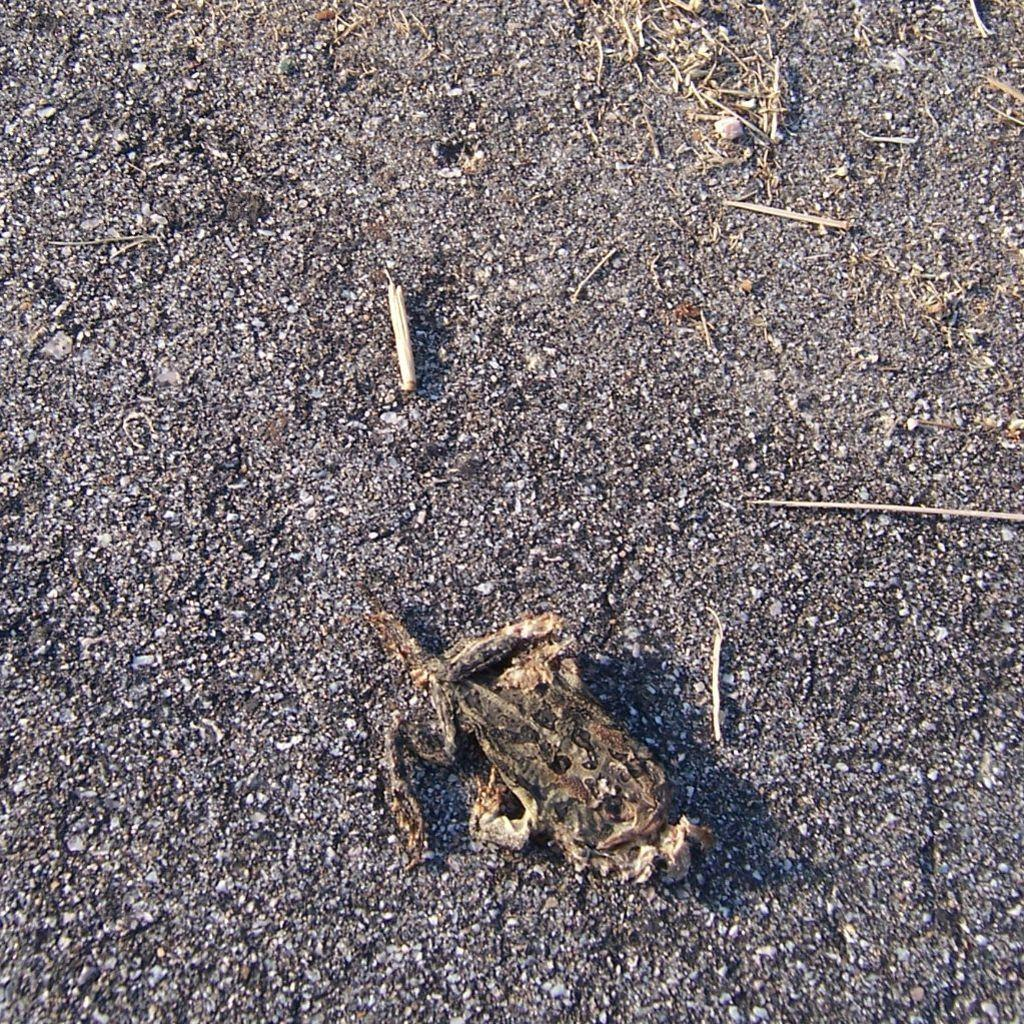What type of material are the pieces in the image made of? The pieces in the image are made of wood. Where are the wooden pieces located? The wooden pieces are on the land. What type of lettuce can be seen growing near the wooden pieces in the image? There is no lettuce present in the image; it only features wooden pieces on the land. 